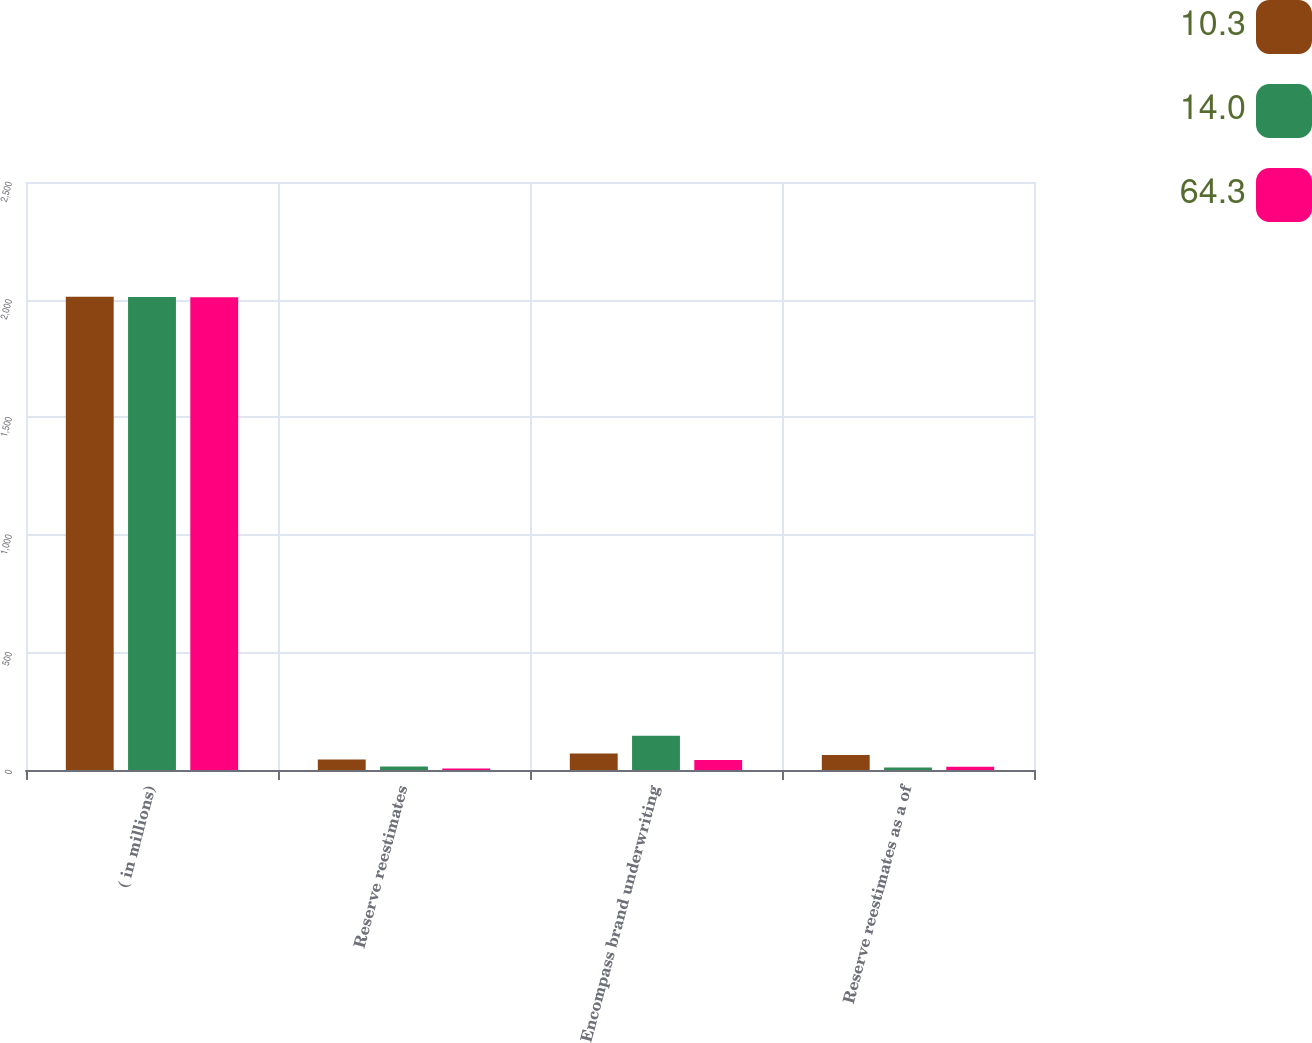Convert chart. <chart><loc_0><loc_0><loc_500><loc_500><stacked_bar_chart><ecel><fcel>( in millions)<fcel>Reserve reestimates<fcel>Encompass brand underwriting<fcel>Reserve reestimates as a of<nl><fcel>10.3<fcel>2012<fcel>45<fcel>70<fcel>64.3<nl><fcel>14<fcel>2011<fcel>15<fcel>146<fcel>10.3<nl><fcel>64.3<fcel>2010<fcel>6<fcel>43<fcel>14<nl></chart> 